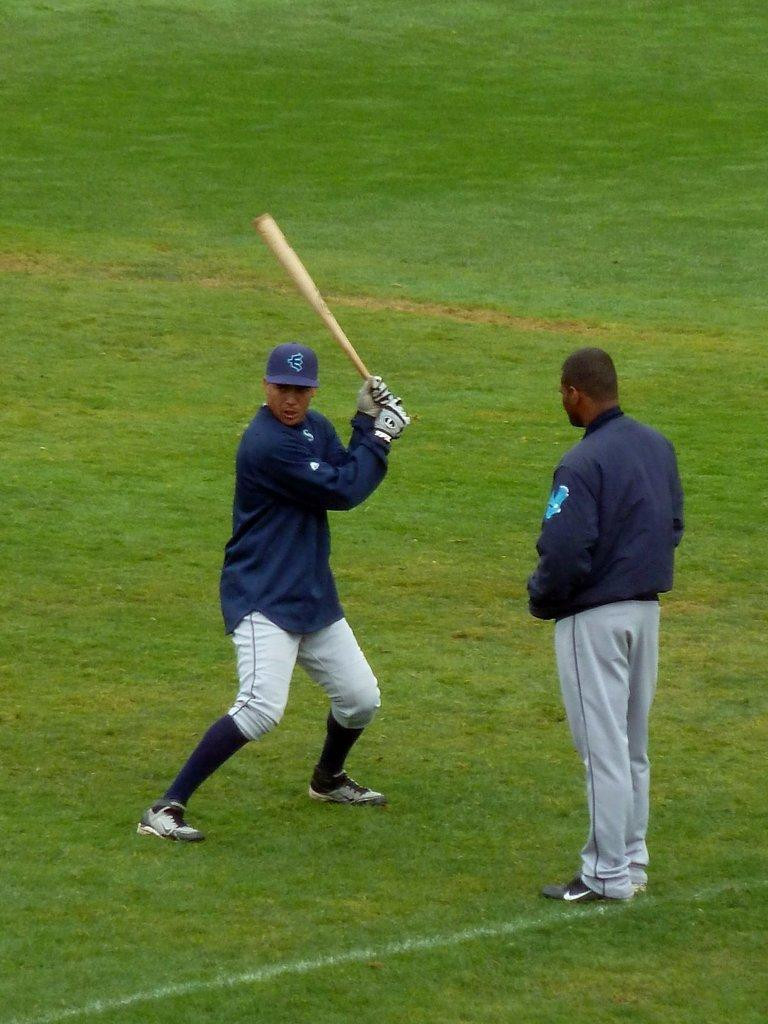What is the person in the image wearing? The person is wearing a blue dress in the image. What is the person standing on? The person is standing on a greenery ground. What object is the person holding? The person is holding a baseball bat. Is there another person in the image? Yes, there is another person standing in front of the person with the baseball bat. Can you see any visible veins on the person's face in the image? There is no information about the person's face or veins in the provided facts, so we cannot answer this question. 